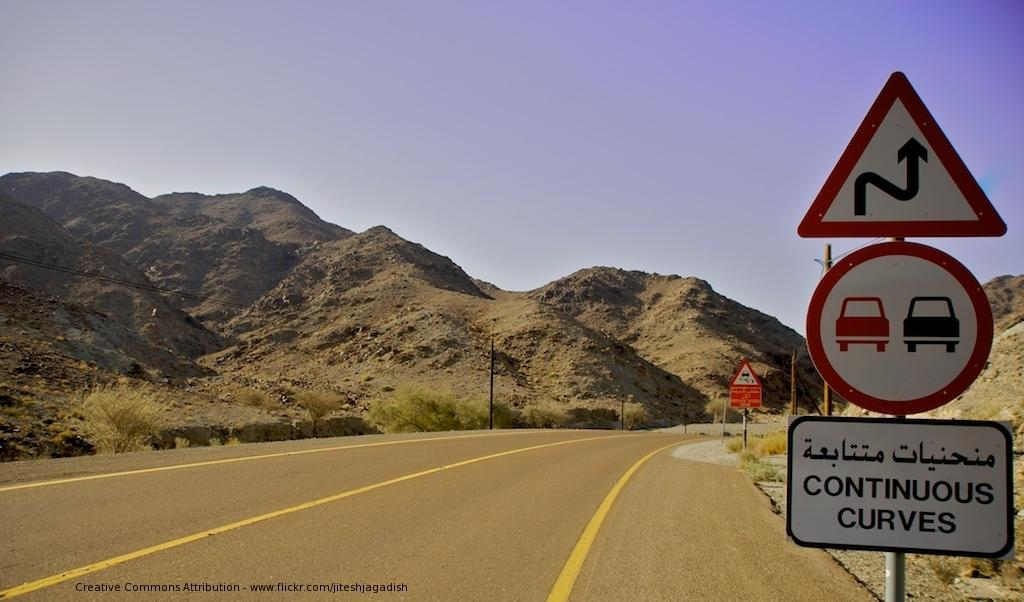<image>
Share a concise interpretation of the image provided. The sign next to this roadway warns drivers that the road is very curvy up ahead. 